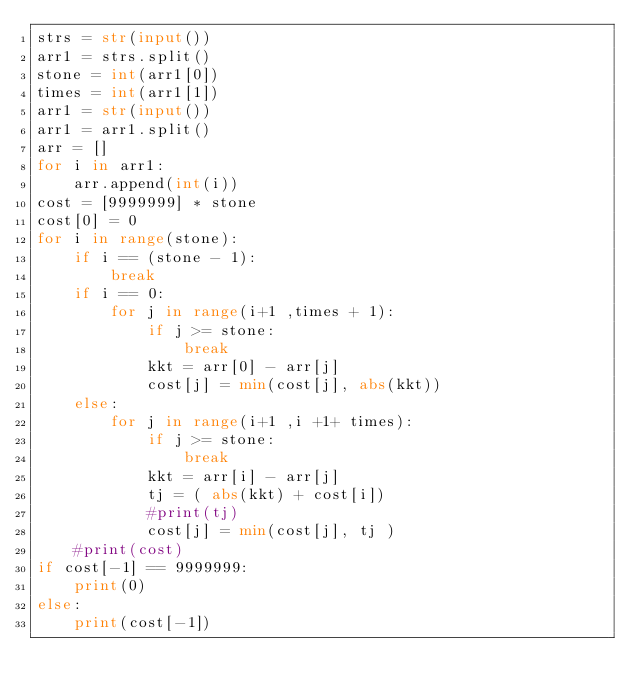Convert code to text. <code><loc_0><loc_0><loc_500><loc_500><_Python_>strs = str(input())
arr1 = strs.split()
stone = int(arr1[0])
times = int(arr1[1])
arr1 = str(input())
arr1 = arr1.split()
arr = []
for i in arr1:
    arr.append(int(i))
cost = [9999999] * stone
cost[0] = 0
for i in range(stone):
    if i == (stone - 1):
        break
    if i == 0:
        for j in range(i+1 ,times + 1):
            if j >= stone:
                break
            kkt = arr[0] - arr[j]
            cost[j] = min(cost[j], abs(kkt))
    else:
        for j in range(i+1 ,i +1+ times):
            if j >= stone:
                break
            kkt = arr[i] - arr[j]
            tj = ( abs(kkt) + cost[i])
            #print(tj)
            cost[j] = min(cost[j], tj )
    #print(cost)
if cost[-1] == 9999999:
    print(0)
else:
    print(cost[-1])
        
        
        
        
        
        
        

</code> 